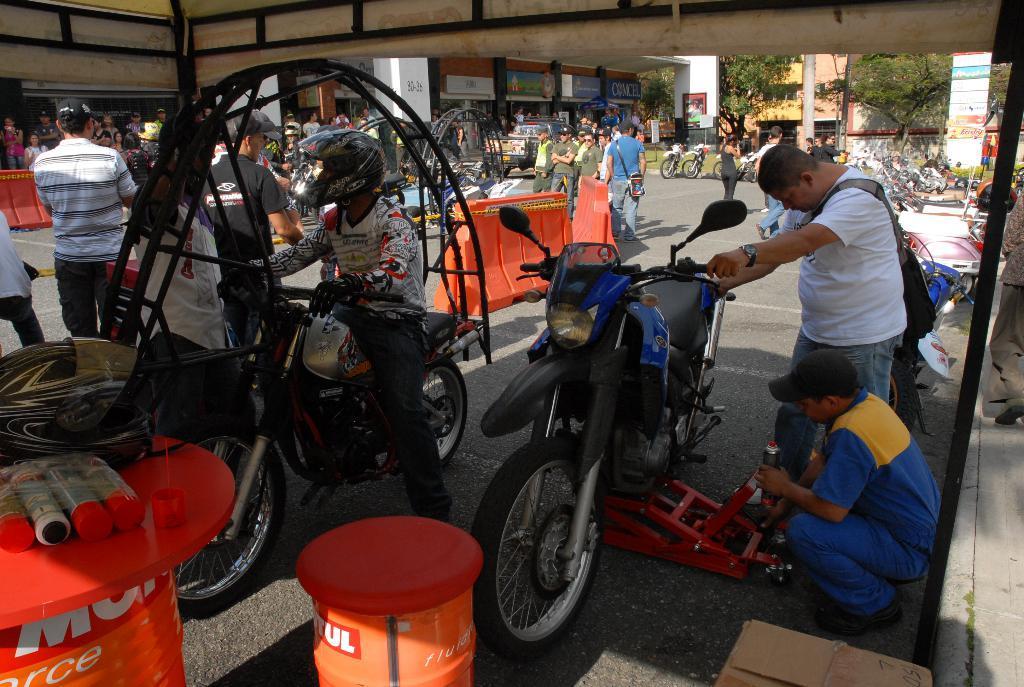In one or two sentences, can you explain what this image depicts? In the image we can see there are people who are standing and people are sitting on the bike and they are serving the bike. 